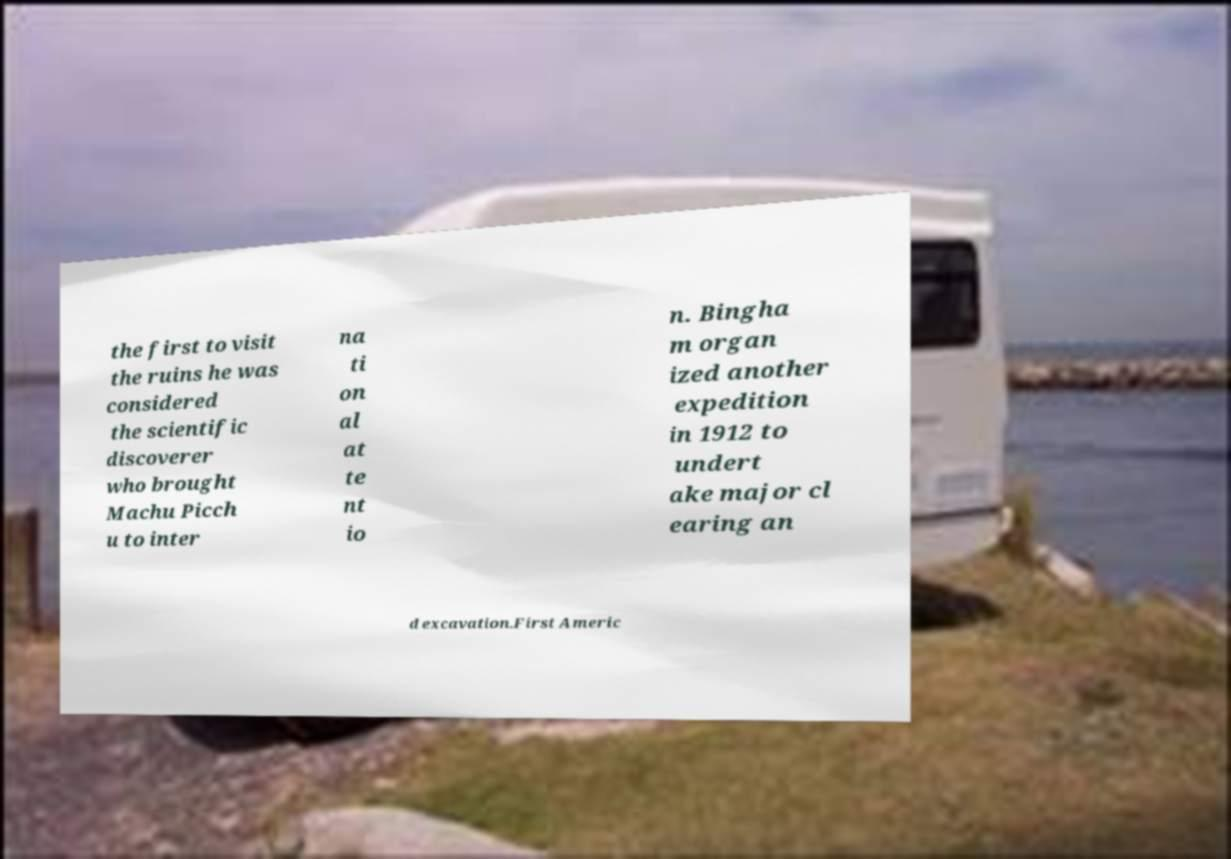There's text embedded in this image that I need extracted. Can you transcribe it verbatim? the first to visit the ruins he was considered the scientific discoverer who brought Machu Picch u to inter na ti on al at te nt io n. Bingha m organ ized another expedition in 1912 to undert ake major cl earing an d excavation.First Americ 